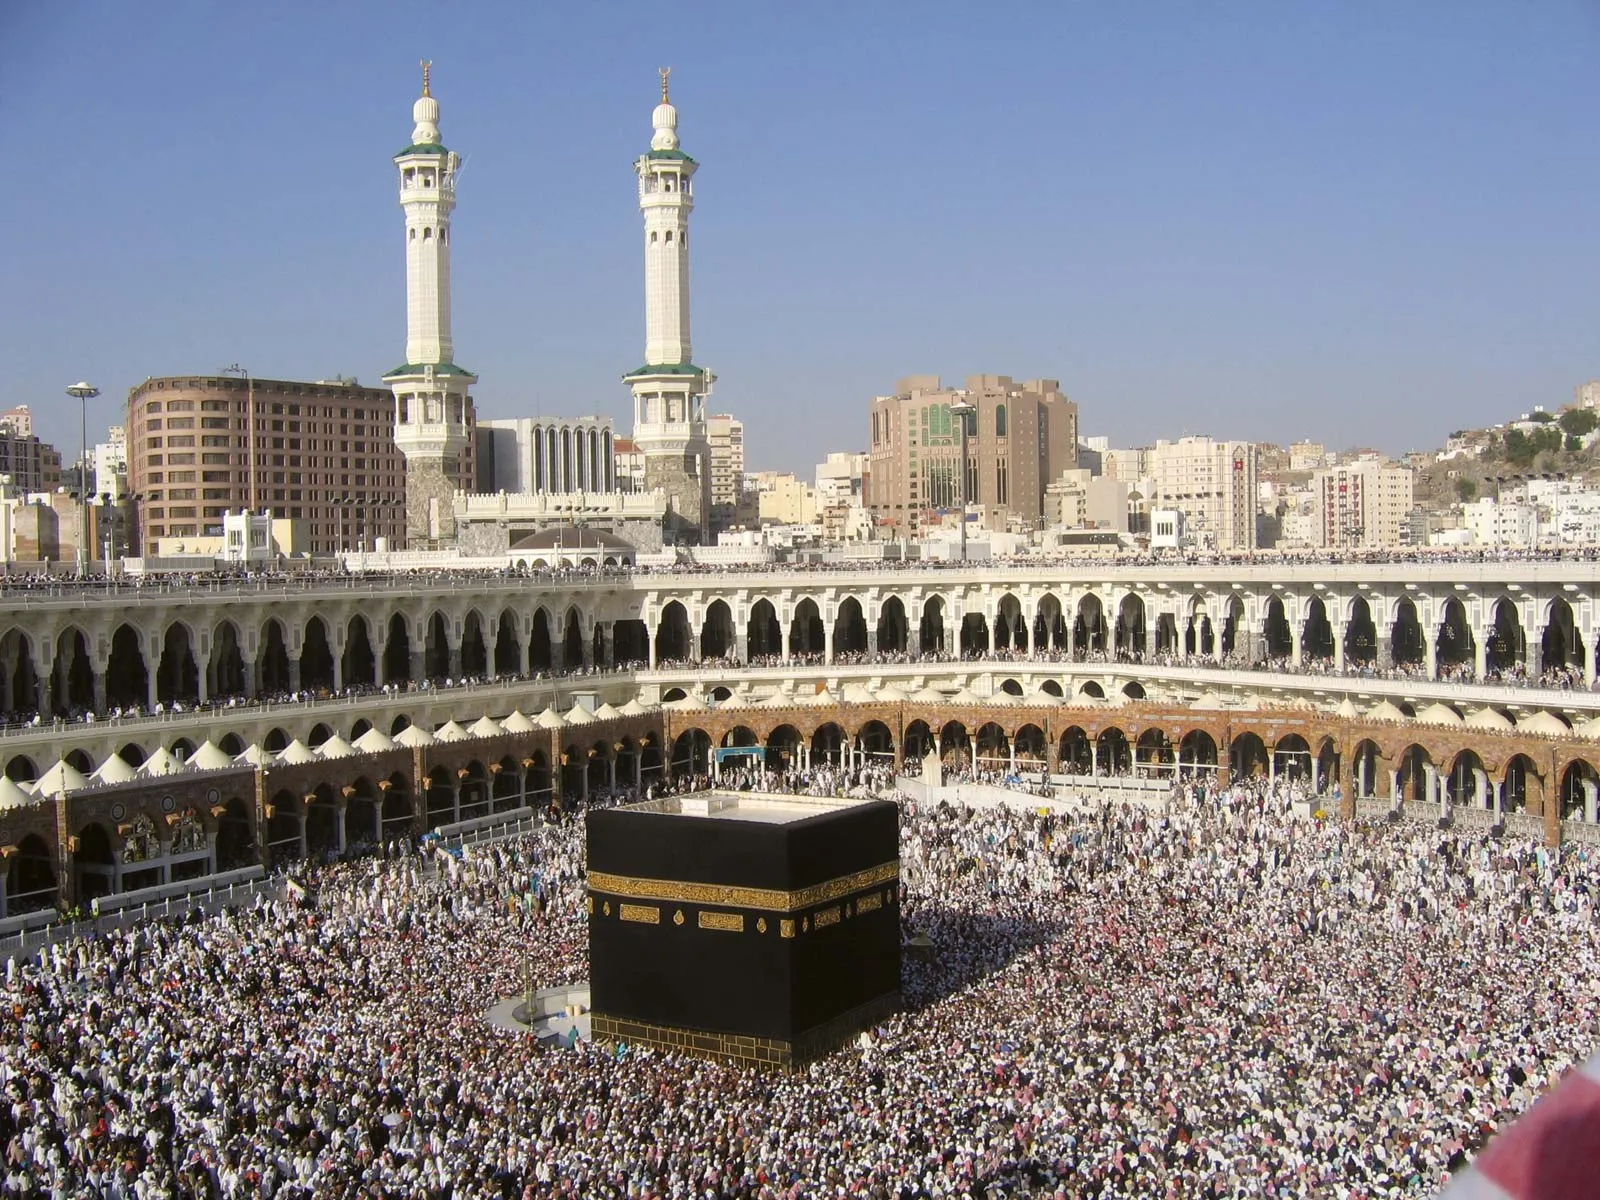Can you explain the significance of the cloth covering the Kaaba? Certainly! The cloth covering the Kaaba is known as the Kiswah. It is traditionally made of silk and cotton, adorned with verses from the Quran embroidered in gold and silver thread. The Kiswah holds immense religious significance as it symbolizes the sanctity and respect Muslims have for the Kaaba. It is replaced annually during the Hajj pilgrimage, symbolizing renewal and continuous devotion. 